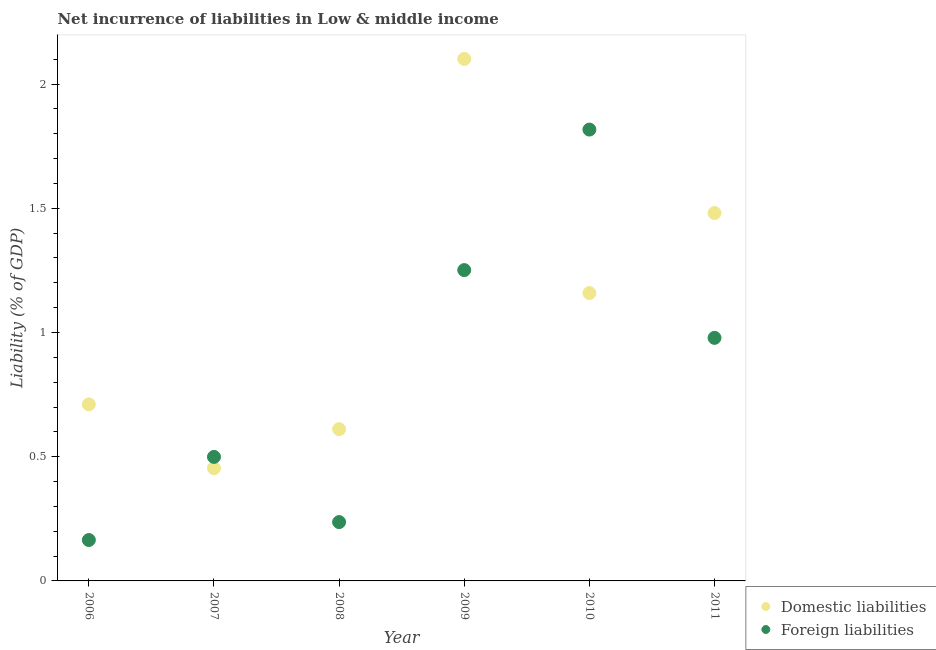How many different coloured dotlines are there?
Your answer should be very brief. 2. What is the incurrence of foreign liabilities in 2009?
Provide a succinct answer. 1.25. Across all years, what is the maximum incurrence of domestic liabilities?
Offer a terse response. 2.1. Across all years, what is the minimum incurrence of foreign liabilities?
Offer a terse response. 0.16. In which year was the incurrence of foreign liabilities minimum?
Your answer should be very brief. 2006. What is the total incurrence of foreign liabilities in the graph?
Make the answer very short. 4.95. What is the difference between the incurrence of domestic liabilities in 2008 and that in 2010?
Provide a succinct answer. -0.55. What is the difference between the incurrence of foreign liabilities in 2011 and the incurrence of domestic liabilities in 2010?
Ensure brevity in your answer.  -0.18. What is the average incurrence of foreign liabilities per year?
Give a very brief answer. 0.82. In the year 2007, what is the difference between the incurrence of domestic liabilities and incurrence of foreign liabilities?
Provide a succinct answer. -0.05. What is the ratio of the incurrence of domestic liabilities in 2007 to that in 2008?
Provide a succinct answer. 0.74. What is the difference between the highest and the second highest incurrence of foreign liabilities?
Your answer should be very brief. 0.57. What is the difference between the highest and the lowest incurrence of foreign liabilities?
Offer a terse response. 1.65. In how many years, is the incurrence of domestic liabilities greater than the average incurrence of domestic liabilities taken over all years?
Ensure brevity in your answer.  3. Is the incurrence of domestic liabilities strictly less than the incurrence of foreign liabilities over the years?
Your answer should be compact. No. How many years are there in the graph?
Ensure brevity in your answer.  6. What is the difference between two consecutive major ticks on the Y-axis?
Offer a very short reply. 0.5. Are the values on the major ticks of Y-axis written in scientific E-notation?
Offer a terse response. No. Does the graph contain any zero values?
Your response must be concise. No. Does the graph contain grids?
Your response must be concise. No. How many legend labels are there?
Your answer should be very brief. 2. What is the title of the graph?
Ensure brevity in your answer.  Net incurrence of liabilities in Low & middle income. What is the label or title of the Y-axis?
Your response must be concise. Liability (% of GDP). What is the Liability (% of GDP) of Domestic liabilities in 2006?
Give a very brief answer. 0.71. What is the Liability (% of GDP) of Foreign liabilities in 2006?
Offer a terse response. 0.16. What is the Liability (% of GDP) in Domestic liabilities in 2007?
Your response must be concise. 0.45. What is the Liability (% of GDP) of Foreign liabilities in 2007?
Provide a succinct answer. 0.5. What is the Liability (% of GDP) of Domestic liabilities in 2008?
Give a very brief answer. 0.61. What is the Liability (% of GDP) of Foreign liabilities in 2008?
Provide a succinct answer. 0.24. What is the Liability (% of GDP) in Domestic liabilities in 2009?
Provide a short and direct response. 2.1. What is the Liability (% of GDP) of Foreign liabilities in 2009?
Your response must be concise. 1.25. What is the Liability (% of GDP) in Domestic liabilities in 2010?
Ensure brevity in your answer.  1.16. What is the Liability (% of GDP) of Foreign liabilities in 2010?
Your response must be concise. 1.82. What is the Liability (% of GDP) in Domestic liabilities in 2011?
Give a very brief answer. 1.48. What is the Liability (% of GDP) in Foreign liabilities in 2011?
Provide a short and direct response. 0.98. Across all years, what is the maximum Liability (% of GDP) in Domestic liabilities?
Ensure brevity in your answer.  2.1. Across all years, what is the maximum Liability (% of GDP) of Foreign liabilities?
Offer a terse response. 1.82. Across all years, what is the minimum Liability (% of GDP) in Domestic liabilities?
Offer a very short reply. 0.45. Across all years, what is the minimum Liability (% of GDP) in Foreign liabilities?
Provide a succinct answer. 0.16. What is the total Liability (% of GDP) in Domestic liabilities in the graph?
Provide a short and direct response. 6.52. What is the total Liability (% of GDP) of Foreign liabilities in the graph?
Ensure brevity in your answer.  4.95. What is the difference between the Liability (% of GDP) in Domestic liabilities in 2006 and that in 2007?
Keep it short and to the point. 0.26. What is the difference between the Liability (% of GDP) of Foreign liabilities in 2006 and that in 2007?
Ensure brevity in your answer.  -0.33. What is the difference between the Liability (% of GDP) in Domestic liabilities in 2006 and that in 2008?
Keep it short and to the point. 0.1. What is the difference between the Liability (% of GDP) in Foreign liabilities in 2006 and that in 2008?
Keep it short and to the point. -0.07. What is the difference between the Liability (% of GDP) of Domestic liabilities in 2006 and that in 2009?
Provide a succinct answer. -1.39. What is the difference between the Liability (% of GDP) of Foreign liabilities in 2006 and that in 2009?
Provide a succinct answer. -1.09. What is the difference between the Liability (% of GDP) in Domestic liabilities in 2006 and that in 2010?
Make the answer very short. -0.45. What is the difference between the Liability (% of GDP) of Foreign liabilities in 2006 and that in 2010?
Give a very brief answer. -1.65. What is the difference between the Liability (% of GDP) in Domestic liabilities in 2006 and that in 2011?
Your response must be concise. -0.77. What is the difference between the Liability (% of GDP) of Foreign liabilities in 2006 and that in 2011?
Offer a very short reply. -0.81. What is the difference between the Liability (% of GDP) in Domestic liabilities in 2007 and that in 2008?
Offer a very short reply. -0.16. What is the difference between the Liability (% of GDP) in Foreign liabilities in 2007 and that in 2008?
Give a very brief answer. 0.26. What is the difference between the Liability (% of GDP) of Domestic liabilities in 2007 and that in 2009?
Ensure brevity in your answer.  -1.65. What is the difference between the Liability (% of GDP) in Foreign liabilities in 2007 and that in 2009?
Offer a terse response. -0.75. What is the difference between the Liability (% of GDP) in Domestic liabilities in 2007 and that in 2010?
Your response must be concise. -0.7. What is the difference between the Liability (% of GDP) of Foreign liabilities in 2007 and that in 2010?
Make the answer very short. -1.32. What is the difference between the Liability (% of GDP) in Domestic liabilities in 2007 and that in 2011?
Make the answer very short. -1.03. What is the difference between the Liability (% of GDP) in Foreign liabilities in 2007 and that in 2011?
Keep it short and to the point. -0.48. What is the difference between the Liability (% of GDP) of Domestic liabilities in 2008 and that in 2009?
Provide a short and direct response. -1.49. What is the difference between the Liability (% of GDP) of Foreign liabilities in 2008 and that in 2009?
Offer a very short reply. -1.01. What is the difference between the Liability (% of GDP) of Domestic liabilities in 2008 and that in 2010?
Keep it short and to the point. -0.55. What is the difference between the Liability (% of GDP) in Foreign liabilities in 2008 and that in 2010?
Ensure brevity in your answer.  -1.58. What is the difference between the Liability (% of GDP) of Domestic liabilities in 2008 and that in 2011?
Your answer should be very brief. -0.87. What is the difference between the Liability (% of GDP) in Foreign liabilities in 2008 and that in 2011?
Your answer should be very brief. -0.74. What is the difference between the Liability (% of GDP) of Domestic liabilities in 2009 and that in 2010?
Keep it short and to the point. 0.94. What is the difference between the Liability (% of GDP) in Foreign liabilities in 2009 and that in 2010?
Offer a terse response. -0.57. What is the difference between the Liability (% of GDP) in Domestic liabilities in 2009 and that in 2011?
Your answer should be compact. 0.62. What is the difference between the Liability (% of GDP) of Foreign liabilities in 2009 and that in 2011?
Your answer should be very brief. 0.27. What is the difference between the Liability (% of GDP) in Domestic liabilities in 2010 and that in 2011?
Make the answer very short. -0.32. What is the difference between the Liability (% of GDP) in Foreign liabilities in 2010 and that in 2011?
Make the answer very short. 0.84. What is the difference between the Liability (% of GDP) of Domestic liabilities in 2006 and the Liability (% of GDP) of Foreign liabilities in 2007?
Make the answer very short. 0.21. What is the difference between the Liability (% of GDP) in Domestic liabilities in 2006 and the Liability (% of GDP) in Foreign liabilities in 2008?
Offer a very short reply. 0.47. What is the difference between the Liability (% of GDP) in Domestic liabilities in 2006 and the Liability (% of GDP) in Foreign liabilities in 2009?
Offer a very short reply. -0.54. What is the difference between the Liability (% of GDP) of Domestic liabilities in 2006 and the Liability (% of GDP) of Foreign liabilities in 2010?
Ensure brevity in your answer.  -1.11. What is the difference between the Liability (% of GDP) of Domestic liabilities in 2006 and the Liability (% of GDP) of Foreign liabilities in 2011?
Ensure brevity in your answer.  -0.27. What is the difference between the Liability (% of GDP) in Domestic liabilities in 2007 and the Liability (% of GDP) in Foreign liabilities in 2008?
Your answer should be very brief. 0.22. What is the difference between the Liability (% of GDP) of Domestic liabilities in 2007 and the Liability (% of GDP) of Foreign liabilities in 2009?
Provide a short and direct response. -0.8. What is the difference between the Liability (% of GDP) of Domestic liabilities in 2007 and the Liability (% of GDP) of Foreign liabilities in 2010?
Offer a terse response. -1.36. What is the difference between the Liability (% of GDP) of Domestic liabilities in 2007 and the Liability (% of GDP) of Foreign liabilities in 2011?
Make the answer very short. -0.52. What is the difference between the Liability (% of GDP) of Domestic liabilities in 2008 and the Liability (% of GDP) of Foreign liabilities in 2009?
Your answer should be compact. -0.64. What is the difference between the Liability (% of GDP) in Domestic liabilities in 2008 and the Liability (% of GDP) in Foreign liabilities in 2010?
Ensure brevity in your answer.  -1.21. What is the difference between the Liability (% of GDP) of Domestic liabilities in 2008 and the Liability (% of GDP) of Foreign liabilities in 2011?
Keep it short and to the point. -0.37. What is the difference between the Liability (% of GDP) of Domestic liabilities in 2009 and the Liability (% of GDP) of Foreign liabilities in 2010?
Give a very brief answer. 0.28. What is the difference between the Liability (% of GDP) of Domestic liabilities in 2009 and the Liability (% of GDP) of Foreign liabilities in 2011?
Ensure brevity in your answer.  1.12. What is the difference between the Liability (% of GDP) in Domestic liabilities in 2010 and the Liability (% of GDP) in Foreign liabilities in 2011?
Offer a very short reply. 0.18. What is the average Liability (% of GDP) of Domestic liabilities per year?
Provide a succinct answer. 1.09. What is the average Liability (% of GDP) in Foreign liabilities per year?
Make the answer very short. 0.82. In the year 2006, what is the difference between the Liability (% of GDP) in Domestic liabilities and Liability (% of GDP) in Foreign liabilities?
Provide a short and direct response. 0.55. In the year 2007, what is the difference between the Liability (% of GDP) of Domestic liabilities and Liability (% of GDP) of Foreign liabilities?
Make the answer very short. -0.05. In the year 2008, what is the difference between the Liability (% of GDP) of Domestic liabilities and Liability (% of GDP) of Foreign liabilities?
Provide a succinct answer. 0.37. In the year 2009, what is the difference between the Liability (% of GDP) in Domestic liabilities and Liability (% of GDP) in Foreign liabilities?
Ensure brevity in your answer.  0.85. In the year 2010, what is the difference between the Liability (% of GDP) in Domestic liabilities and Liability (% of GDP) in Foreign liabilities?
Give a very brief answer. -0.66. In the year 2011, what is the difference between the Liability (% of GDP) of Domestic liabilities and Liability (% of GDP) of Foreign liabilities?
Make the answer very short. 0.5. What is the ratio of the Liability (% of GDP) of Domestic liabilities in 2006 to that in 2007?
Keep it short and to the point. 1.57. What is the ratio of the Liability (% of GDP) in Foreign liabilities in 2006 to that in 2007?
Make the answer very short. 0.33. What is the ratio of the Liability (% of GDP) of Domestic liabilities in 2006 to that in 2008?
Ensure brevity in your answer.  1.16. What is the ratio of the Liability (% of GDP) of Foreign liabilities in 2006 to that in 2008?
Offer a very short reply. 0.7. What is the ratio of the Liability (% of GDP) in Domestic liabilities in 2006 to that in 2009?
Your answer should be very brief. 0.34. What is the ratio of the Liability (% of GDP) of Foreign liabilities in 2006 to that in 2009?
Ensure brevity in your answer.  0.13. What is the ratio of the Liability (% of GDP) of Domestic liabilities in 2006 to that in 2010?
Provide a succinct answer. 0.61. What is the ratio of the Liability (% of GDP) of Foreign liabilities in 2006 to that in 2010?
Make the answer very short. 0.09. What is the ratio of the Liability (% of GDP) in Domestic liabilities in 2006 to that in 2011?
Offer a terse response. 0.48. What is the ratio of the Liability (% of GDP) in Foreign liabilities in 2006 to that in 2011?
Your answer should be very brief. 0.17. What is the ratio of the Liability (% of GDP) in Domestic liabilities in 2007 to that in 2008?
Ensure brevity in your answer.  0.74. What is the ratio of the Liability (% of GDP) in Foreign liabilities in 2007 to that in 2008?
Offer a terse response. 2.11. What is the ratio of the Liability (% of GDP) in Domestic liabilities in 2007 to that in 2009?
Offer a terse response. 0.22. What is the ratio of the Liability (% of GDP) in Foreign liabilities in 2007 to that in 2009?
Your answer should be compact. 0.4. What is the ratio of the Liability (% of GDP) in Domestic liabilities in 2007 to that in 2010?
Offer a very short reply. 0.39. What is the ratio of the Liability (% of GDP) of Foreign liabilities in 2007 to that in 2010?
Your answer should be very brief. 0.27. What is the ratio of the Liability (% of GDP) of Domestic liabilities in 2007 to that in 2011?
Your answer should be compact. 0.31. What is the ratio of the Liability (% of GDP) of Foreign liabilities in 2007 to that in 2011?
Provide a short and direct response. 0.51. What is the ratio of the Liability (% of GDP) of Domestic liabilities in 2008 to that in 2009?
Provide a succinct answer. 0.29. What is the ratio of the Liability (% of GDP) of Foreign liabilities in 2008 to that in 2009?
Make the answer very short. 0.19. What is the ratio of the Liability (% of GDP) in Domestic liabilities in 2008 to that in 2010?
Keep it short and to the point. 0.53. What is the ratio of the Liability (% of GDP) in Foreign liabilities in 2008 to that in 2010?
Ensure brevity in your answer.  0.13. What is the ratio of the Liability (% of GDP) in Domestic liabilities in 2008 to that in 2011?
Provide a succinct answer. 0.41. What is the ratio of the Liability (% of GDP) in Foreign liabilities in 2008 to that in 2011?
Give a very brief answer. 0.24. What is the ratio of the Liability (% of GDP) of Domestic liabilities in 2009 to that in 2010?
Provide a short and direct response. 1.81. What is the ratio of the Liability (% of GDP) of Foreign liabilities in 2009 to that in 2010?
Offer a very short reply. 0.69. What is the ratio of the Liability (% of GDP) in Domestic liabilities in 2009 to that in 2011?
Provide a succinct answer. 1.42. What is the ratio of the Liability (% of GDP) in Foreign liabilities in 2009 to that in 2011?
Your response must be concise. 1.28. What is the ratio of the Liability (% of GDP) in Domestic liabilities in 2010 to that in 2011?
Your response must be concise. 0.78. What is the ratio of the Liability (% of GDP) in Foreign liabilities in 2010 to that in 2011?
Provide a succinct answer. 1.86. What is the difference between the highest and the second highest Liability (% of GDP) in Domestic liabilities?
Your answer should be very brief. 0.62. What is the difference between the highest and the second highest Liability (% of GDP) of Foreign liabilities?
Offer a very short reply. 0.57. What is the difference between the highest and the lowest Liability (% of GDP) in Domestic liabilities?
Provide a short and direct response. 1.65. What is the difference between the highest and the lowest Liability (% of GDP) in Foreign liabilities?
Your answer should be very brief. 1.65. 